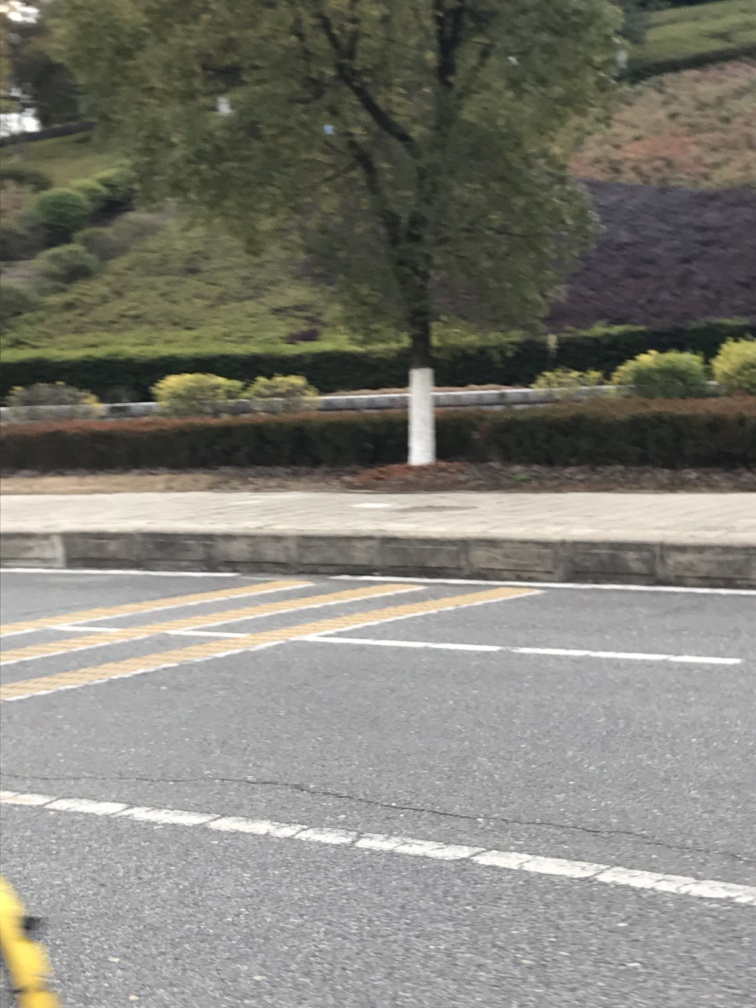What can the image indicate about the speed at which the vehicle was moving when the photo was taken? The degree of motion blur in the image, particularly at the edges and on the road markings, suggests that the vehicle was moving at a moderate to high speed when the photo was taken. 